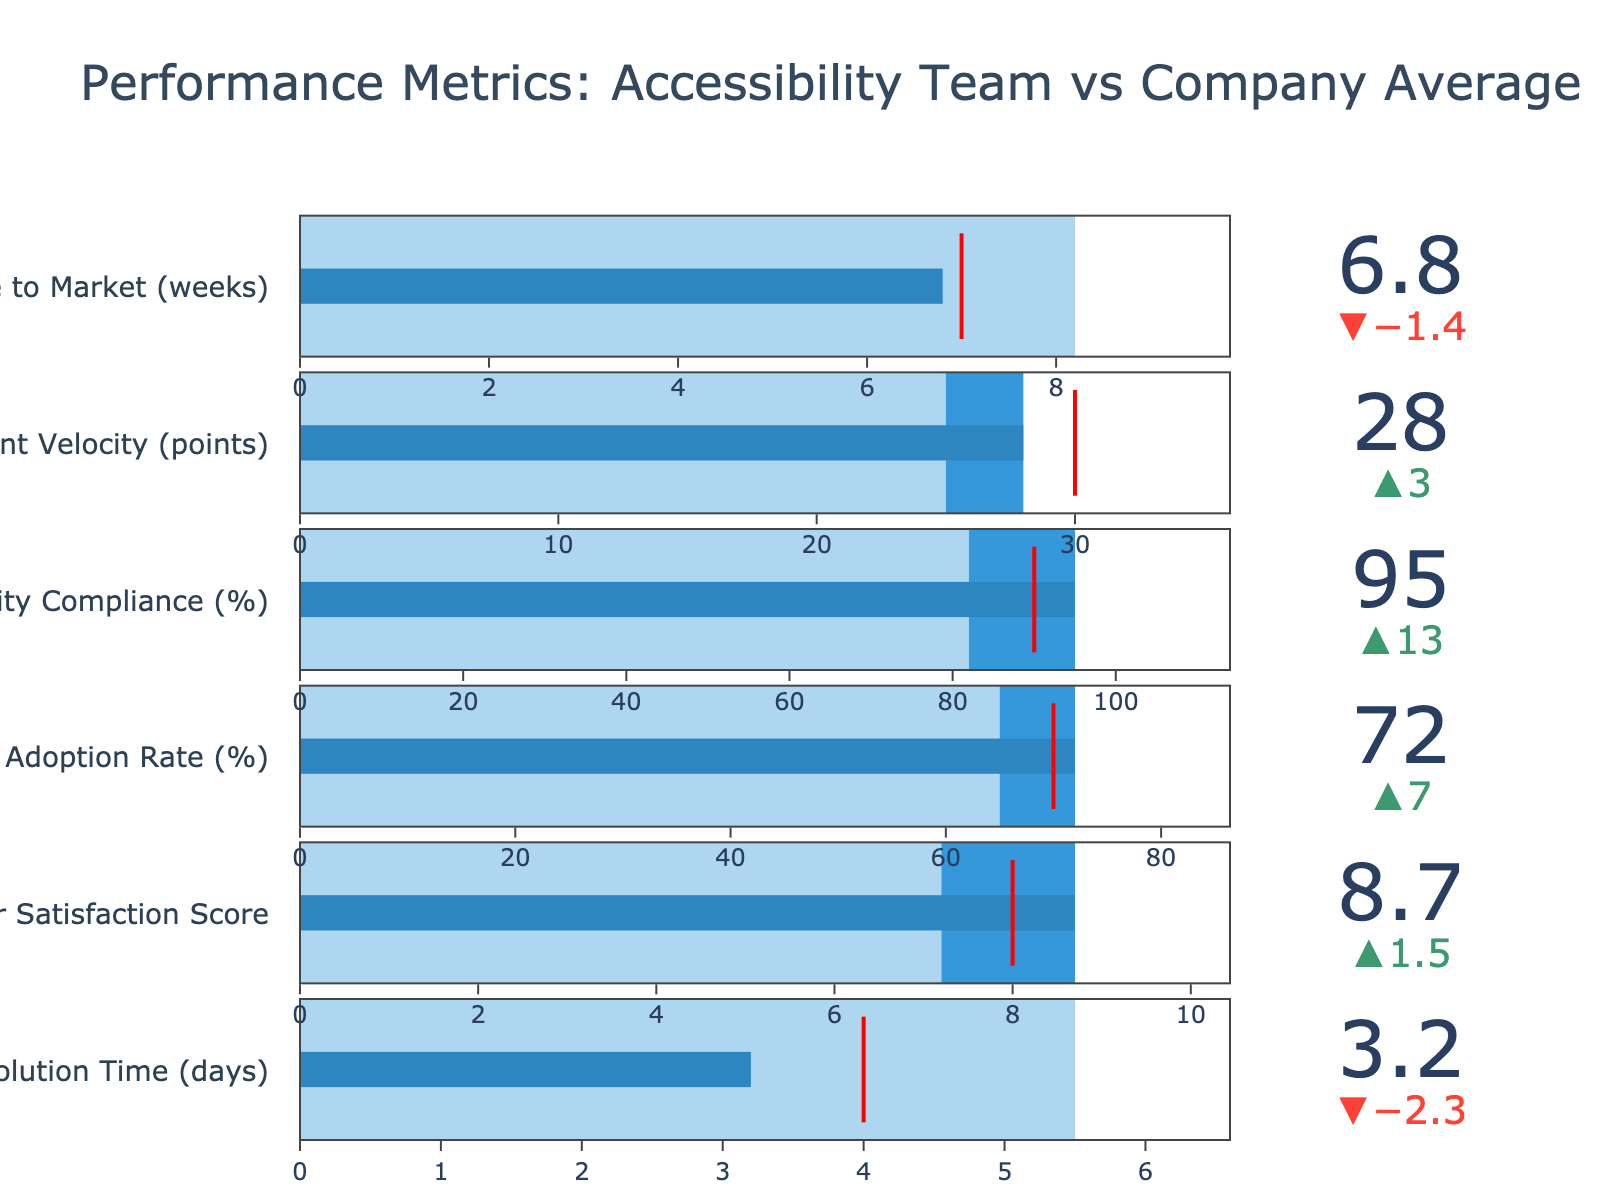What is the title of the figure? The title is usually displayed at the top of the figure.
Answer: "Performance Metrics: Accessibility Team vs Company Average" How many performance metrics are displayed in the figure? By counting the number of bullet indicators in the figure, you can determine the number of metrics displayed.
Answer: 6 Which metric shows the largest difference in performance between the Accessibility Team and the Company Average? By comparing the delta values of each metric, you can see the relative differences in performance. "Accessibility Compliance (%)" shows the largest difference.
Answer: Accessibility Compliance (%) What is the target value for Sprint Velocity (points)? Look for the threshold line, usually marked in red, which indicates the target value for this metric.
Answer: 30 How does the "Bug Resolution Time (days)" of the Accessibility Team compare to the Company Average? Compare the values of the Accessibility Team and the Company Average for "Bug Resolution Time (days)". The Accessibility Team's value is 3.2 days, and the Company Average is 5.5 days.
Answer: It is lower Which team meets or exceeds the target for "User Satisfaction Score"? Compare the Accessibility Team's and Company Average's values to the target value for "User Satisfaction Score". The Accessibility Team meets the target (8.7 vs. 8), while the Company Average does not (7.2 vs. 8).
Answer: Accessibility Team What is the difference between the Accessibility Team's and the Company Average's Time to Market (weeks)? Subtract the Company Average value from the Accessibility Team's value for "Time to Market (weeks)". 8.2 - 6.8 = 1.4.
Answer: 1.4 weeks For which metrics does the Accessibility Team outperform the Company Average? Compare the values of the Accessibility Team and the Company Average across all metrics. The Accessibility Team outperforms in "Bug Resolution Time (days)", "User Satisfaction Score", "Feature Adoption Rate (%)", "Accessibility Compliance (%)", "Sprint Velocity (points)", and "Time to Market (weeks)".
Answer: All listed metrics How close is the Accessibility Team's Feature Adoption Rate (%) to the target? Subtract the Feature Adoption Rate target value from the Accessibility Team's value. 72 - 70 = 2.
Answer: 2% Is the Accessibility Team's Sprint Velocity (points) above or below the Company Average? Compare the values of the Accessibility Team's Sprint Velocity (points) to the Company Average. 28 vs. 25.
Answer: Above How much higher is the Accessibility Team's Accessibility Compliance (%) compared to the Company Average? Subtract the Company Average value from the Accessibility Team's value for Accessibility Compliance (%). 95 - 82 = 13.
Answer: 13% 